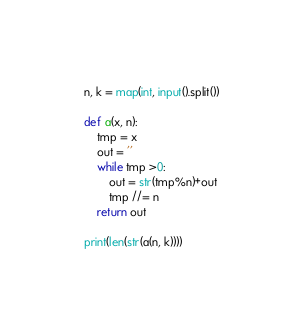Convert code to text. <code><loc_0><loc_0><loc_500><loc_500><_Python_>n, k = map(int, input().split())

def a(x, n):
    tmp = x
    out = ''
    while tmp >0:
        out = str(tmp%n)+out
        tmp //= n
    return out

print(len(str(a(n, k))))</code> 